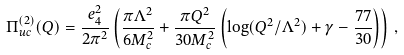Convert formula to latex. <formula><loc_0><loc_0><loc_500><loc_500>\Pi _ { u c } ^ { ( 2 ) } ( Q ) = \frac { e _ { 4 } ^ { 2 } } { 2 \pi ^ { 2 } } \left ( \frac { \pi \Lambda ^ { 2 } } { 6 M _ { c } ^ { 2 } } + \frac { \pi Q ^ { 2 } } { 3 0 M _ { c } ^ { 2 } } \left ( \log ( Q ^ { 2 } / \Lambda ^ { 2 } ) + \gamma - \frac { 7 7 } { 3 0 } \right ) \right ) \, ,</formula> 